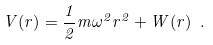<formula> <loc_0><loc_0><loc_500><loc_500>V ( r ) = \frac { 1 } { 2 } m \omega ^ { 2 } r ^ { 2 } + W ( r ) \ .</formula> 